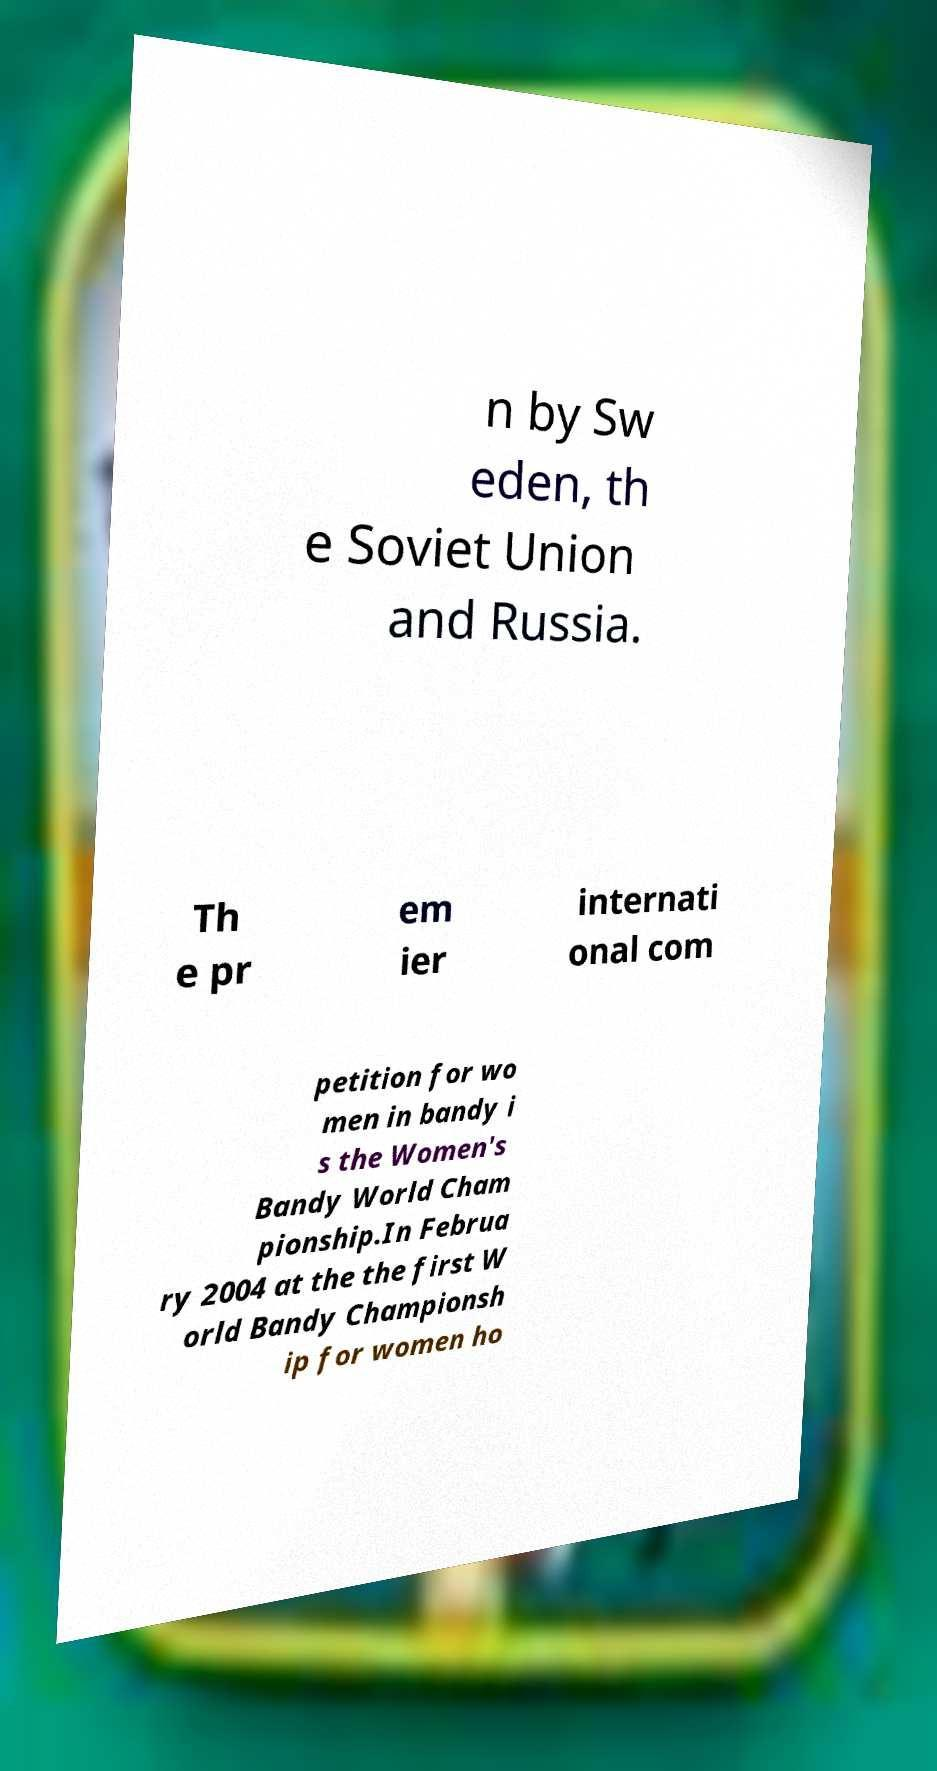What messages or text are displayed in this image? I need them in a readable, typed format. n by Sw eden, th e Soviet Union and Russia. Th e pr em ier internati onal com petition for wo men in bandy i s the Women's Bandy World Cham pionship.In Februa ry 2004 at the the first W orld Bandy Championsh ip for women ho 